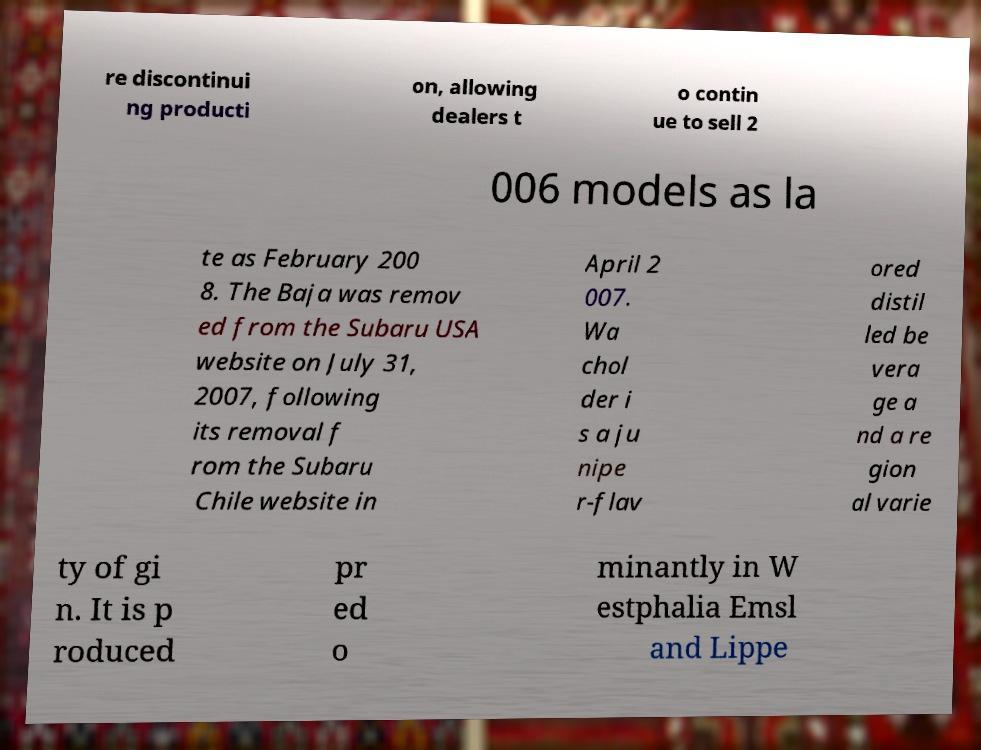Please identify and transcribe the text found in this image. re discontinui ng producti on, allowing dealers t o contin ue to sell 2 006 models as la te as February 200 8. The Baja was remov ed from the Subaru USA website on July 31, 2007, following its removal f rom the Subaru Chile website in April 2 007. Wa chol der i s a ju nipe r-flav ored distil led be vera ge a nd a re gion al varie ty of gi n. It is p roduced pr ed o minantly in W estphalia Emsl and Lippe 